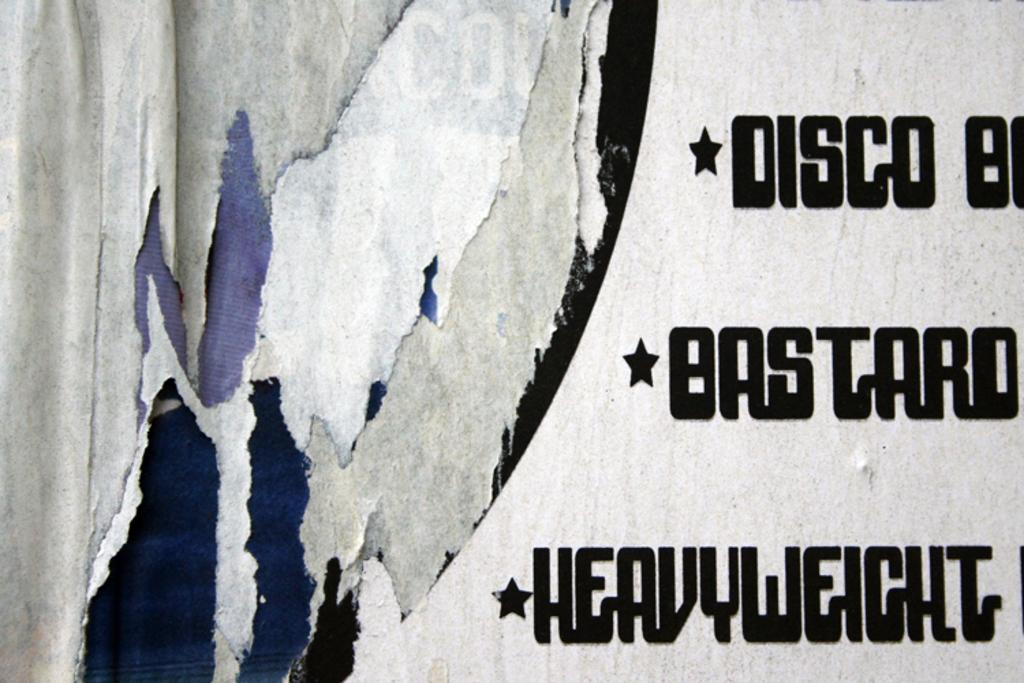What can be seen in the image that is related to language or communication? There are words written in the image. Can you see the partner playing on the playground in the image? There is no partner or playground present in the image; it only contains words. 